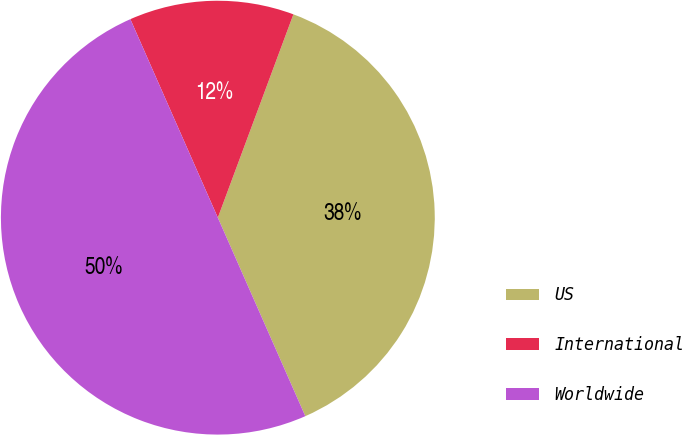Convert chart. <chart><loc_0><loc_0><loc_500><loc_500><pie_chart><fcel>US<fcel>International<fcel>Worldwide<nl><fcel>37.73%<fcel>12.27%<fcel>50.0%<nl></chart> 